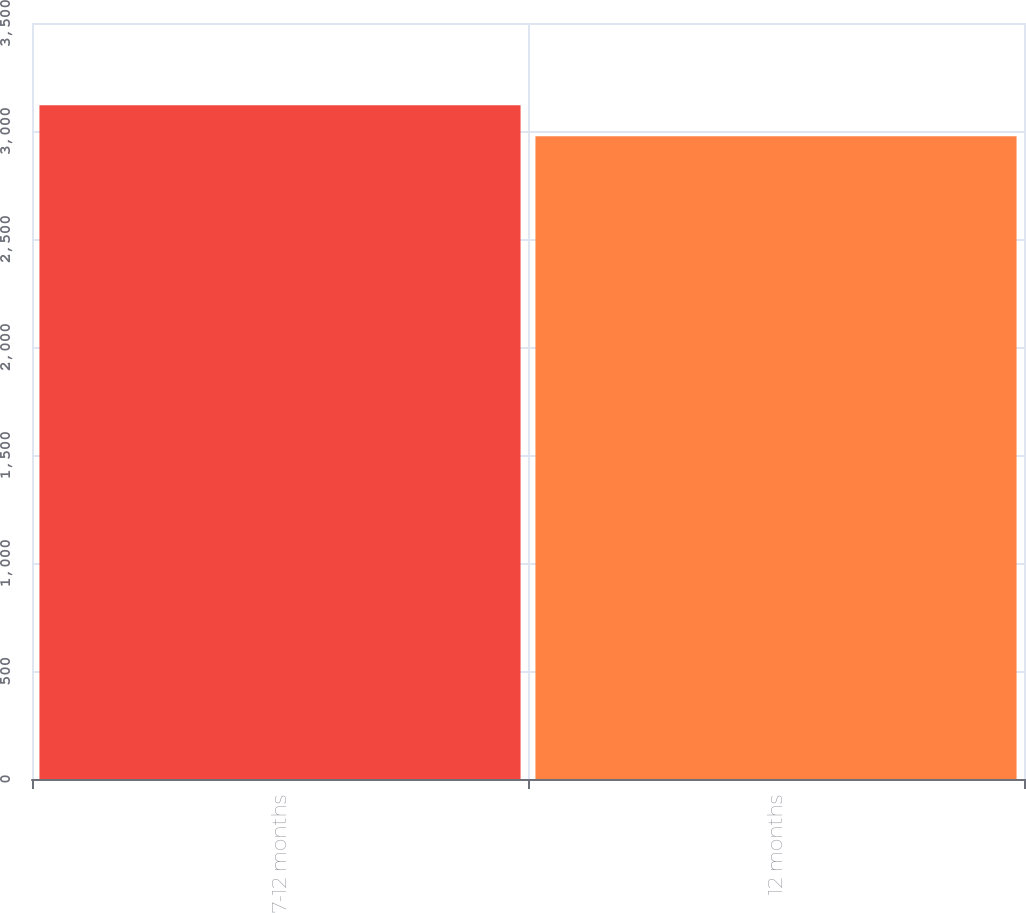Convert chart. <chart><loc_0><loc_0><loc_500><loc_500><bar_chart><fcel>7-12 months<fcel>12 months<nl><fcel>3119<fcel>2976<nl></chart> 